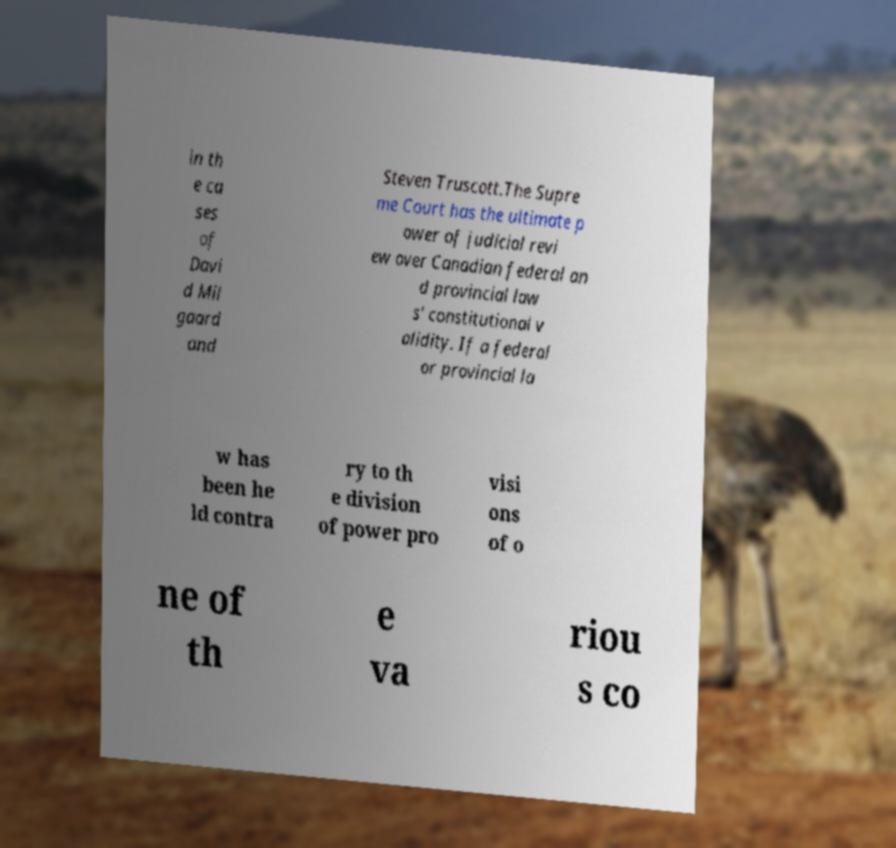Can you accurately transcribe the text from the provided image for me? in th e ca ses of Davi d Mil gaard and Steven Truscott.The Supre me Court has the ultimate p ower of judicial revi ew over Canadian federal an d provincial law s' constitutional v alidity. If a federal or provincial la w has been he ld contra ry to th e division of power pro visi ons of o ne of th e va riou s co 